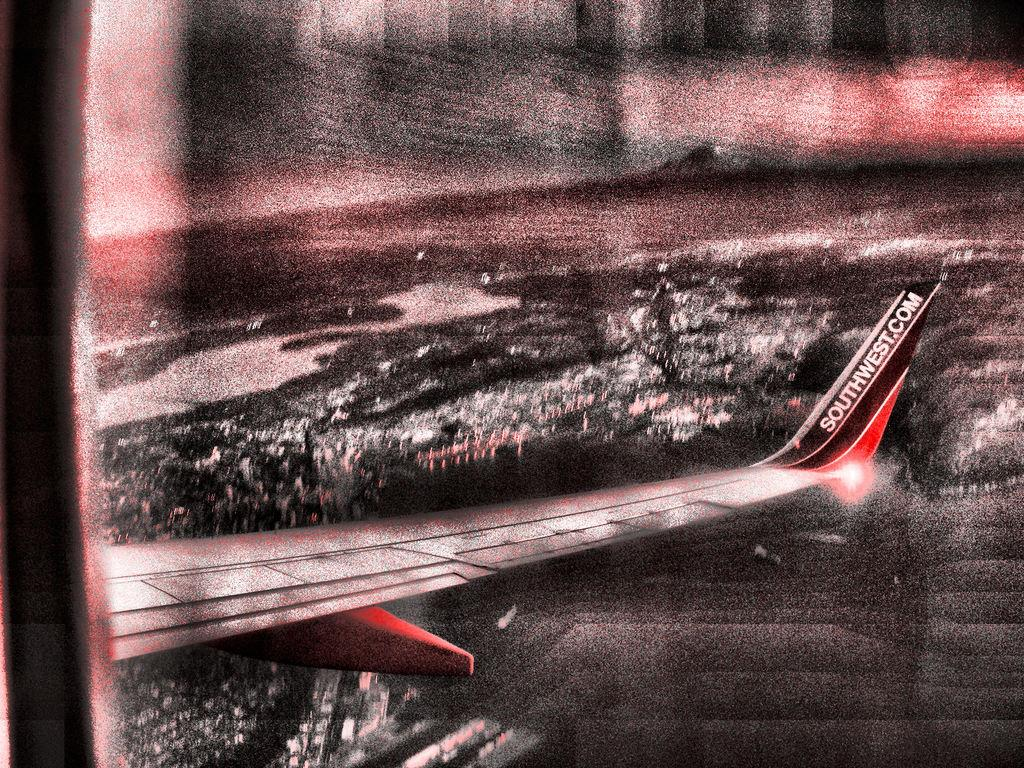Provide a one-sentence caption for the provided image. The right wing of a Southwest airplane is seen above a lit city. 